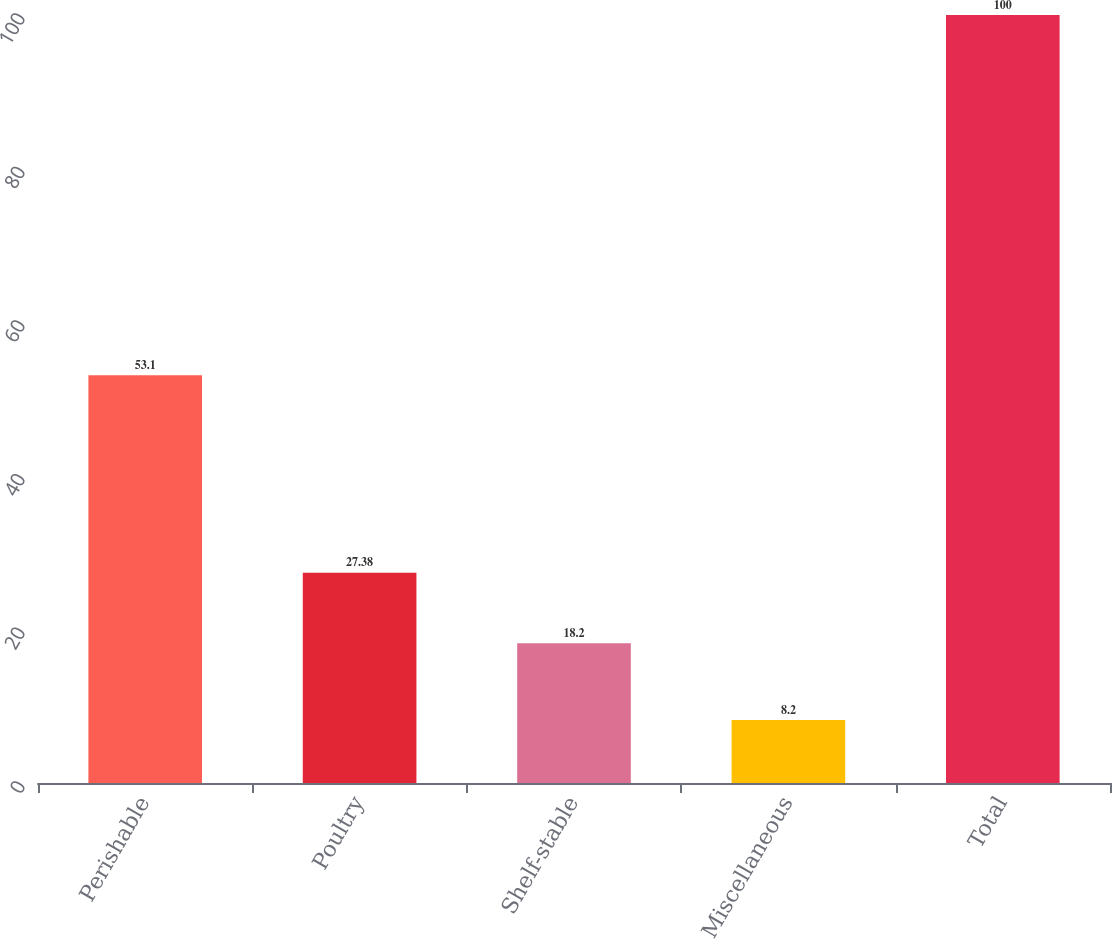<chart> <loc_0><loc_0><loc_500><loc_500><bar_chart><fcel>Perishable<fcel>Poultry<fcel>Shelf-stable<fcel>Miscellaneous<fcel>Total<nl><fcel>53.1<fcel>27.38<fcel>18.2<fcel>8.2<fcel>100<nl></chart> 